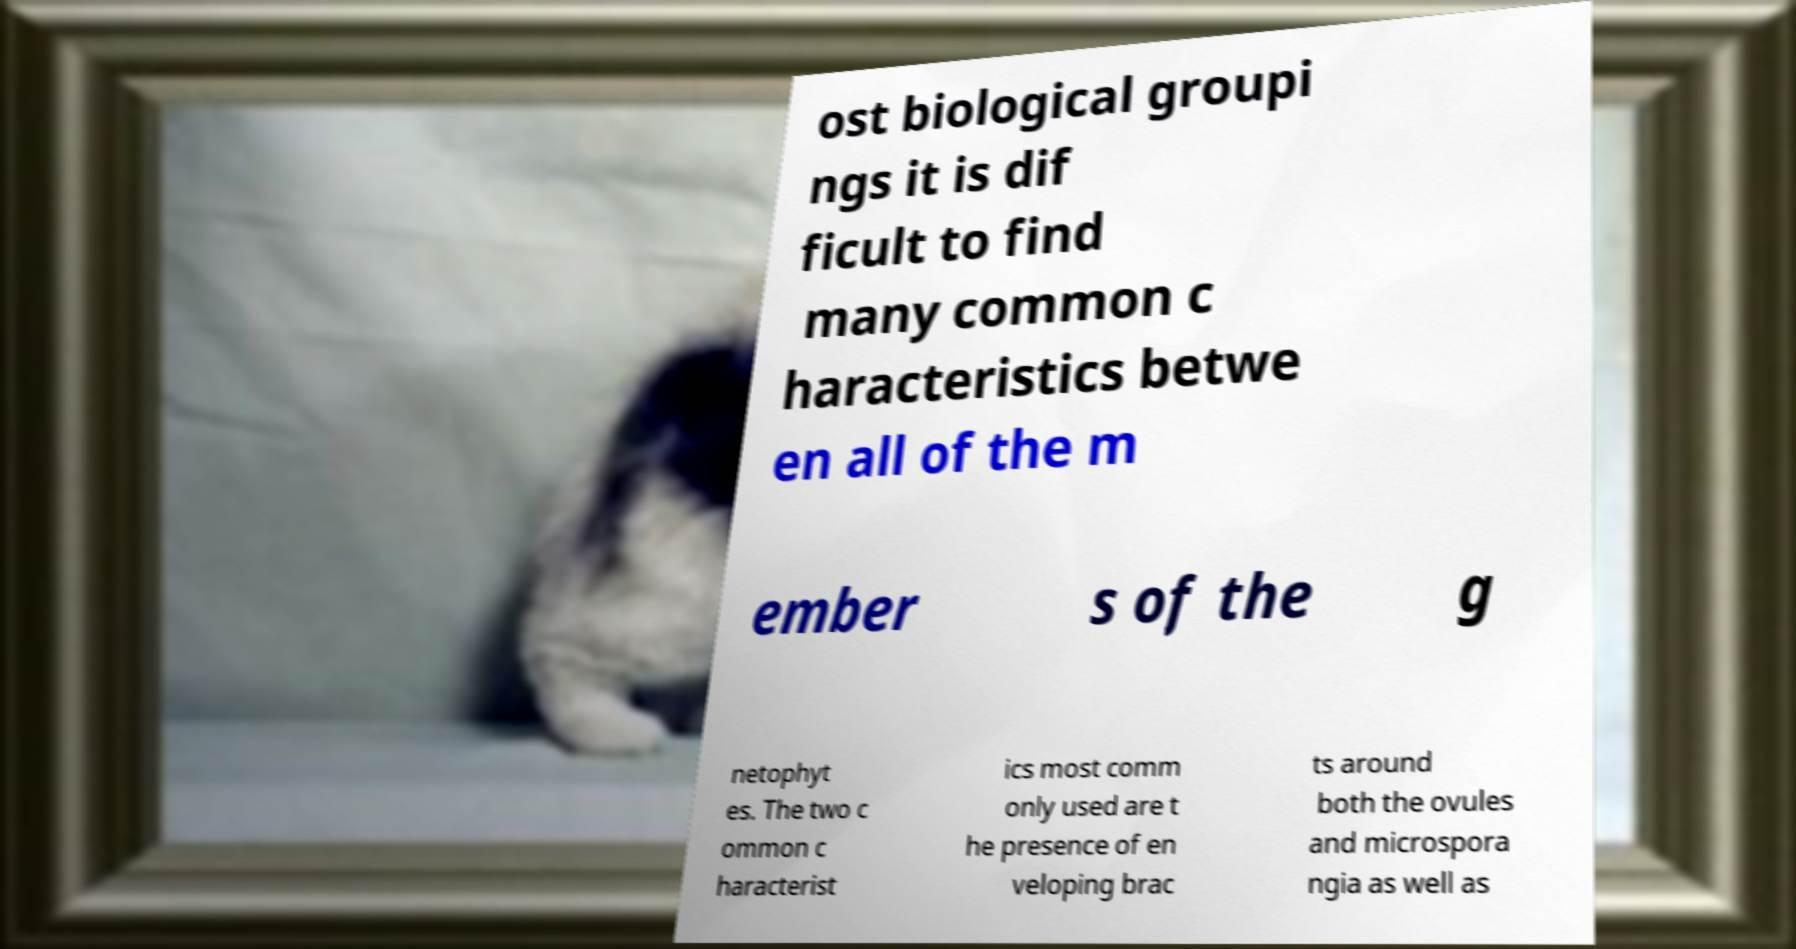What messages or text are displayed in this image? I need them in a readable, typed format. ost biological groupi ngs it is dif ficult to find many common c haracteristics betwe en all of the m ember s of the g netophyt es. The two c ommon c haracterist ics most comm only used are t he presence of en veloping brac ts around both the ovules and microspora ngia as well as 